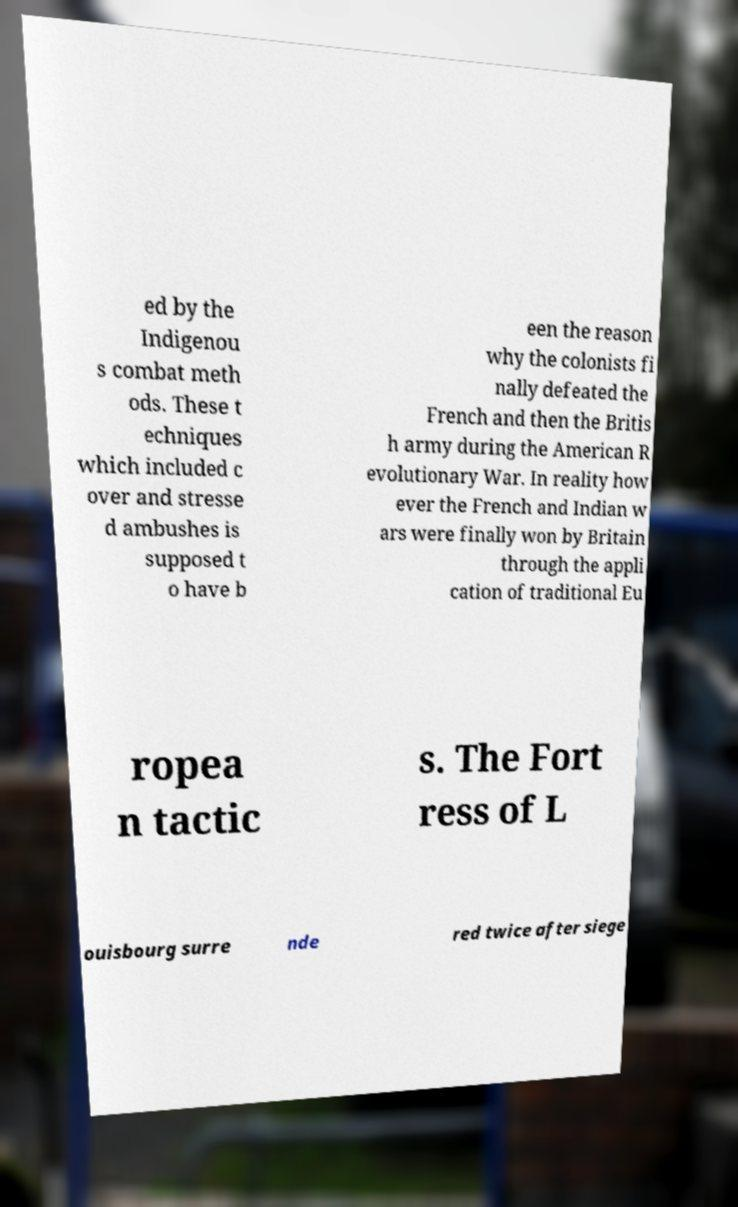Please identify and transcribe the text found in this image. ed by the Indigenou s combat meth ods. These t echniques which included c over and stresse d ambushes is supposed t o have b een the reason why the colonists fi nally defeated the French and then the Britis h army during the American R evolutionary War. In reality how ever the French and Indian w ars were finally won by Britain through the appli cation of traditional Eu ropea n tactic s. The Fort ress of L ouisbourg surre nde red twice after siege 